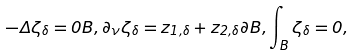<formula> <loc_0><loc_0><loc_500><loc_500>- \Delta \zeta _ { \delta } = 0 { B } , \partial _ { \nu } \zeta _ { \delta } = z _ { 1 , \delta } + z _ { 2 , \delta } \partial { B } , \int _ { B } \zeta _ { \delta } = 0 ,</formula> 